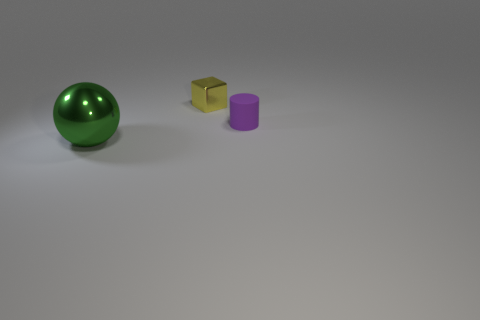The purple matte object is what shape?
Offer a terse response. Cylinder. There is a metallic object that is to the right of the green ball; does it have the same size as the shiny ball in front of the yellow metallic cube?
Your answer should be compact. No. What is the size of the metallic object that is on the left side of the metallic object that is on the right side of the object that is left of the small yellow shiny object?
Your answer should be very brief. Large. The thing that is to the right of the small metal cube that is behind the small thing that is right of the yellow block is what shape?
Your answer should be very brief. Cylinder. What shape is the small thing to the left of the rubber object?
Offer a very short reply. Cube. Is the large sphere made of the same material as the tiny thing that is right of the yellow metal thing?
Make the answer very short. No. How many other things are there of the same shape as the large green thing?
Provide a short and direct response. 0. Is the color of the rubber cylinder the same as the metallic thing to the left of the tiny metal thing?
Provide a short and direct response. No. Are there any other things that have the same material as the yellow cube?
Provide a short and direct response. Yes. The metal thing right of the object left of the small yellow metal thing is what shape?
Your answer should be very brief. Cube. 